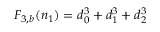Convert formula to latex. <formula><loc_0><loc_0><loc_500><loc_500>F _ { 3 , b } ( n _ { 1 } ) = d _ { 0 } ^ { 3 } + d _ { 1 } ^ { 3 } + d _ { 2 } ^ { 3 }</formula> 